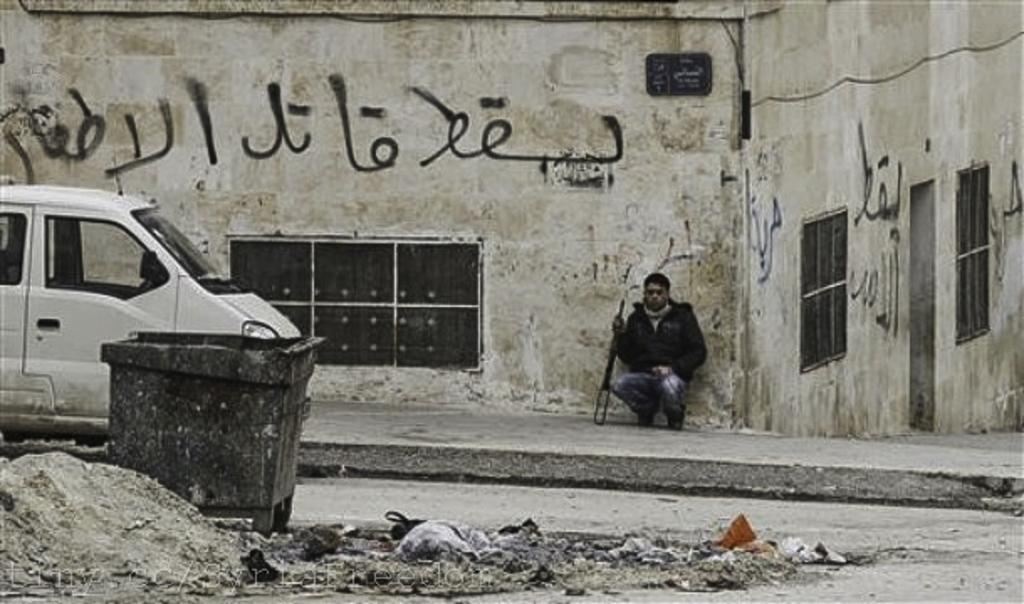What is the color scheme of the image? The image is black and white. What is the man in the image doing? The man is sitting in front of a building. Where is the man located in relation to the building? The man is on a footpath. What can be seen on the left side of the image? There is a van on the left side of the image. How is the van positioned in relation to the dustbin? The van is in front of a dustbin on the road. What type of quince is hanging from the tree in the image? There is no tree or quince present in the image. Can you see any stars in the sky in the image? The image is black and white, and there is no indication of a sky or stars. What invention is the man using to sit in front of the building? The image does not show any specific invention being used by the man to sit. 